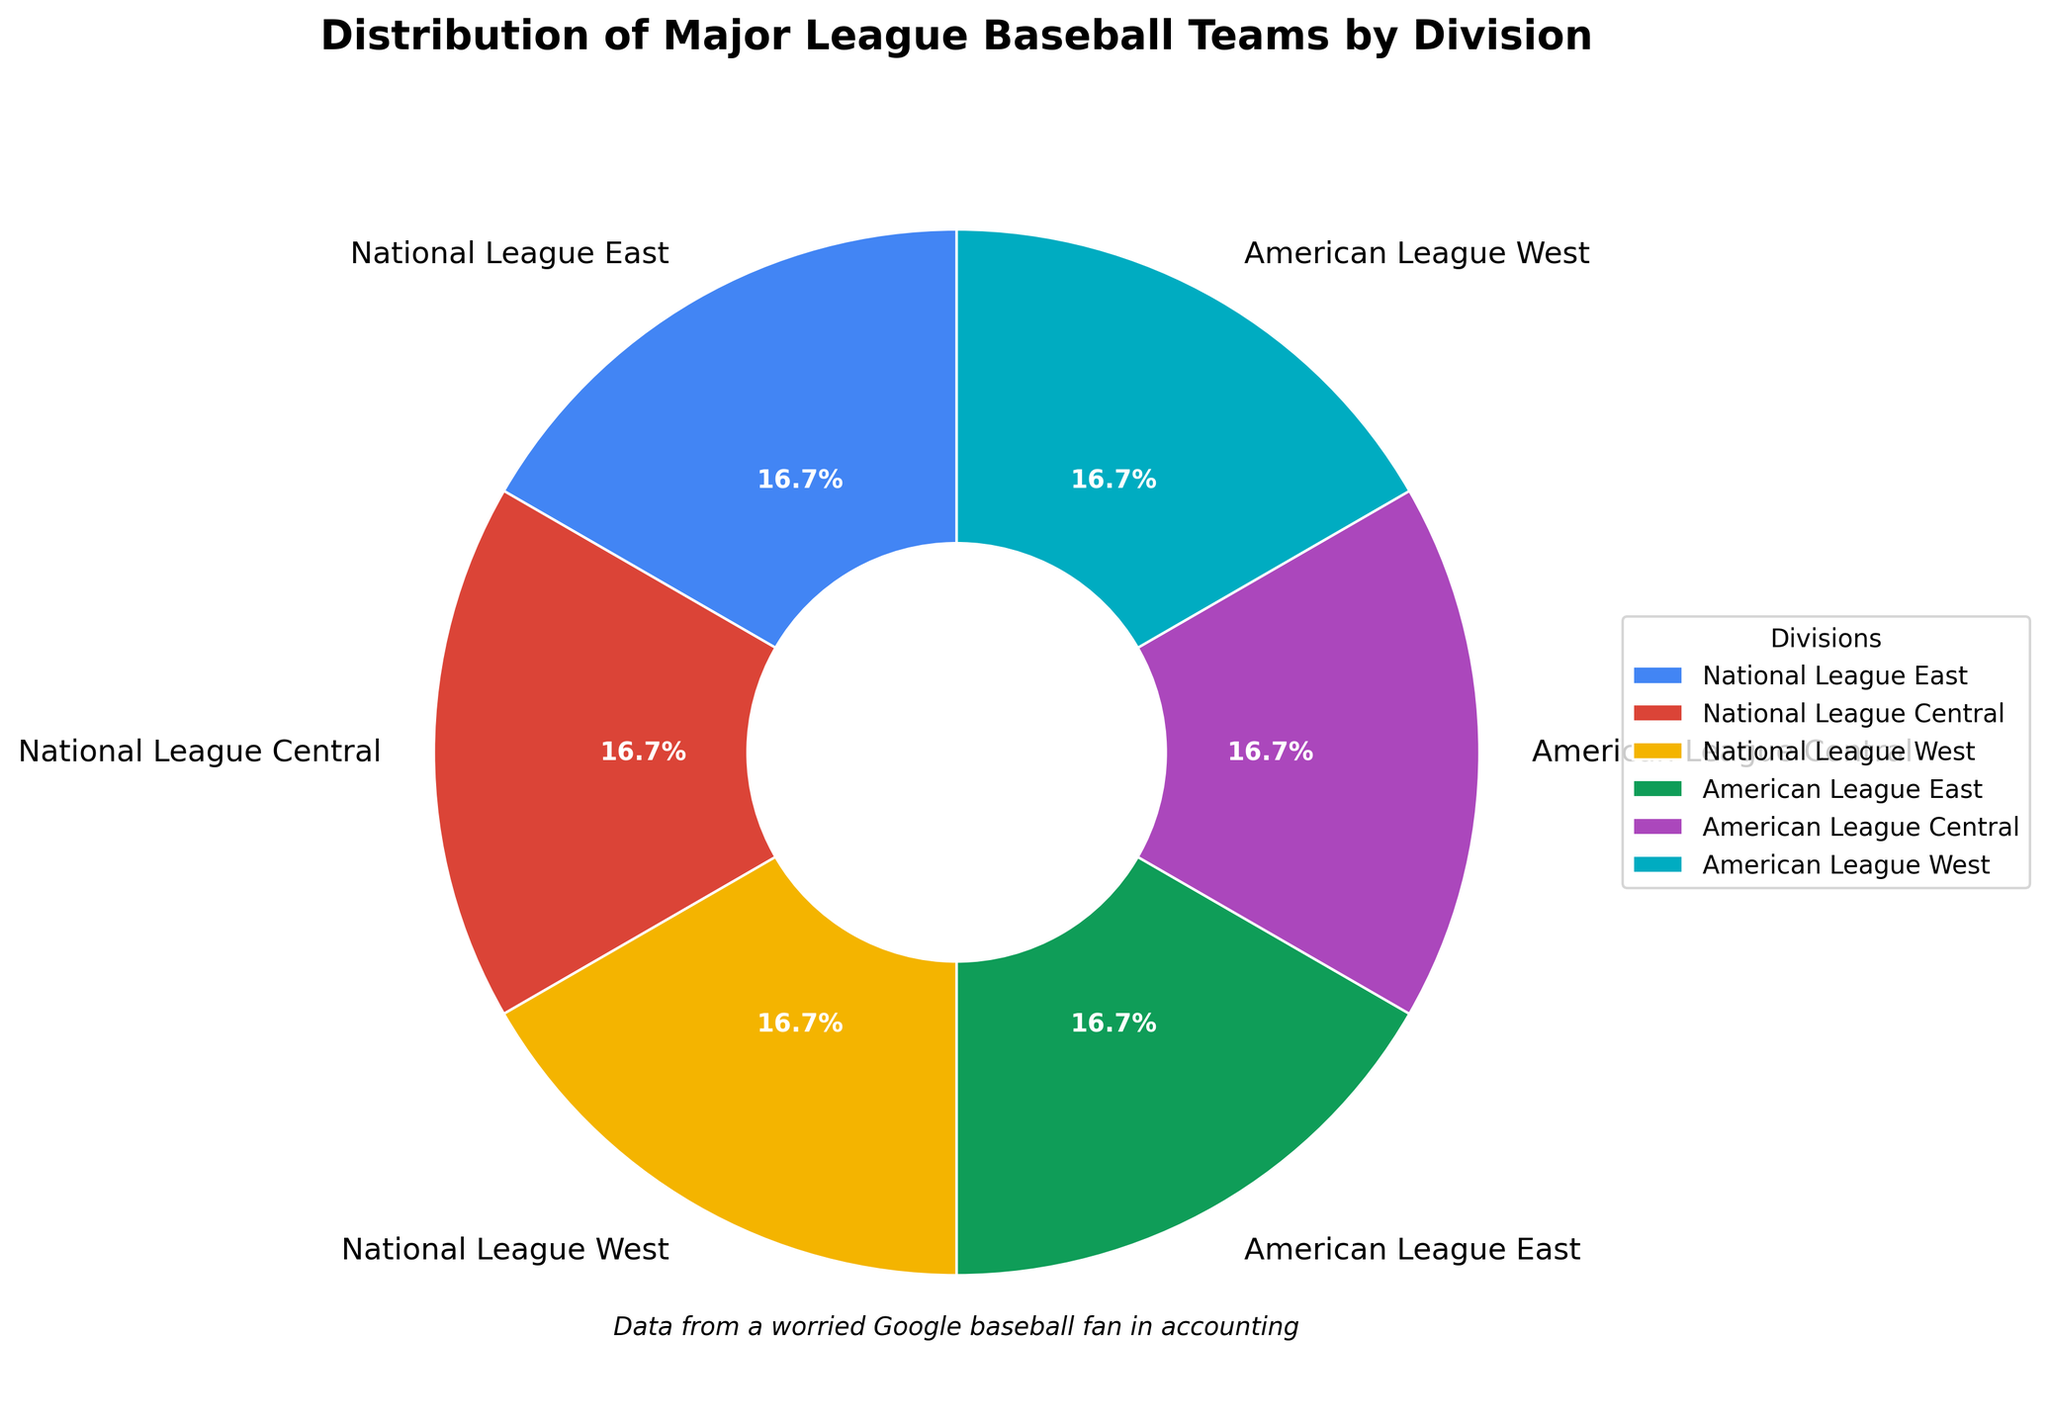What percentage of the total teams are in the National League West? The National League West has 5 teams out of a total of 30 teams. The percentage is calculated as (5/30) * 100.
Answer: 16.7% How many teams are there in the American League Central and National League Central combined? The American League Central has 5 teams and the National League Central also has 5 teams. The total is 5 + 5.
Answer: 10 Which division has the smallest number of teams? The pie chart shows that all divisions have the same number of teams, as each has an equal-sized slice.
Answer: All divisions have the same number Is the number of teams in the American League the same as in the National League? Both the American League and the National League have 15 teams each, as each league consists of 3 divisions of 5 teams each.
Answer: Yes What fraction of the teams are in the American League West? The American League West has 5 teams out of a total of 30 teams. The fraction is 5/30, which simplifies to 1/6.
Answer: 1/6 Which division has more teams: the National League East or the American League East? The pie chart shows that both the National League East and the American League East have the same number of teams.
Answer: They have the same number What is the combined percentage of teams in the National League East and the American League East? Each of these divisions has 5 teams, so combined, they have 10 teams out of 30 total. The percentage is (10/30) * 100.
Answer: 33.3% If 2 teams were added to the American League East, how many teams would it then have? The American League East currently has 5 teams. Adding 2 teams would result in a total of 5 + 2.
Answer: 7 How many more teams does the National League Central have compared to the American League Central? The pie chart shows that the National League Central and the American League Central each have 5 teams. The difference is 5 - 5.
Answer: 0 Which division’s portion of the pie chart is the smallest in size? All divisions' portions of the pie chart are of equal size, indicating no single division is smaller or larger.
Answer: All portions are the same 